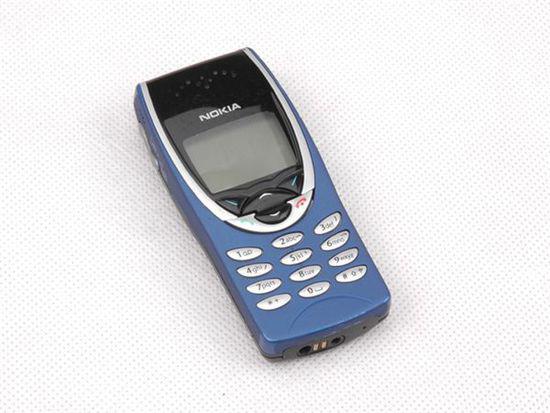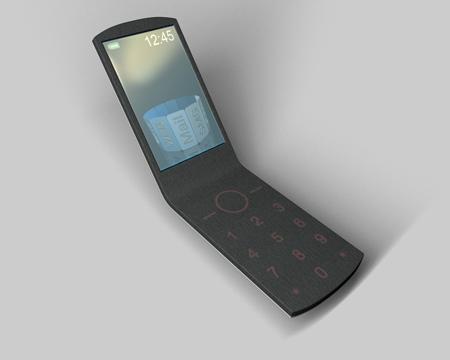The first image is the image on the left, the second image is the image on the right. Considering the images on both sides, is "In at least one image a there is a single phone with physical buttons on the bottom half of the phone that is attached to a phone screen that is long left to right than up and down." valid? Answer yes or no. No. 